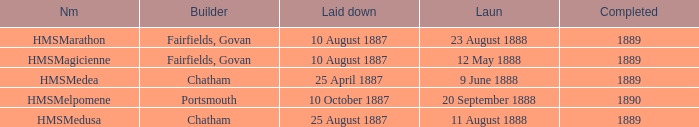Parse the table in full. {'header': ['Nm', 'Builder', 'Laid down', 'Laun', 'Completed'], 'rows': [['HMSMarathon', 'Fairfields, Govan', '10 August 1887', '23 August 1888', '1889'], ['HMSMagicienne', 'Fairfields, Govan', '10 August 1887', '12 May 1888', '1889'], ['HMSMedea', 'Chatham', '25 April 1887', '9 June 1888', '1889'], ['HMSMelpomene', 'Portsmouth', '10 October 1887', '20 September 1888', '1890'], ['HMSMedusa', 'Chatham', '25 August 1887', '11 August 1888', '1889']]} Which constructor finished after 1889? Portsmouth. 